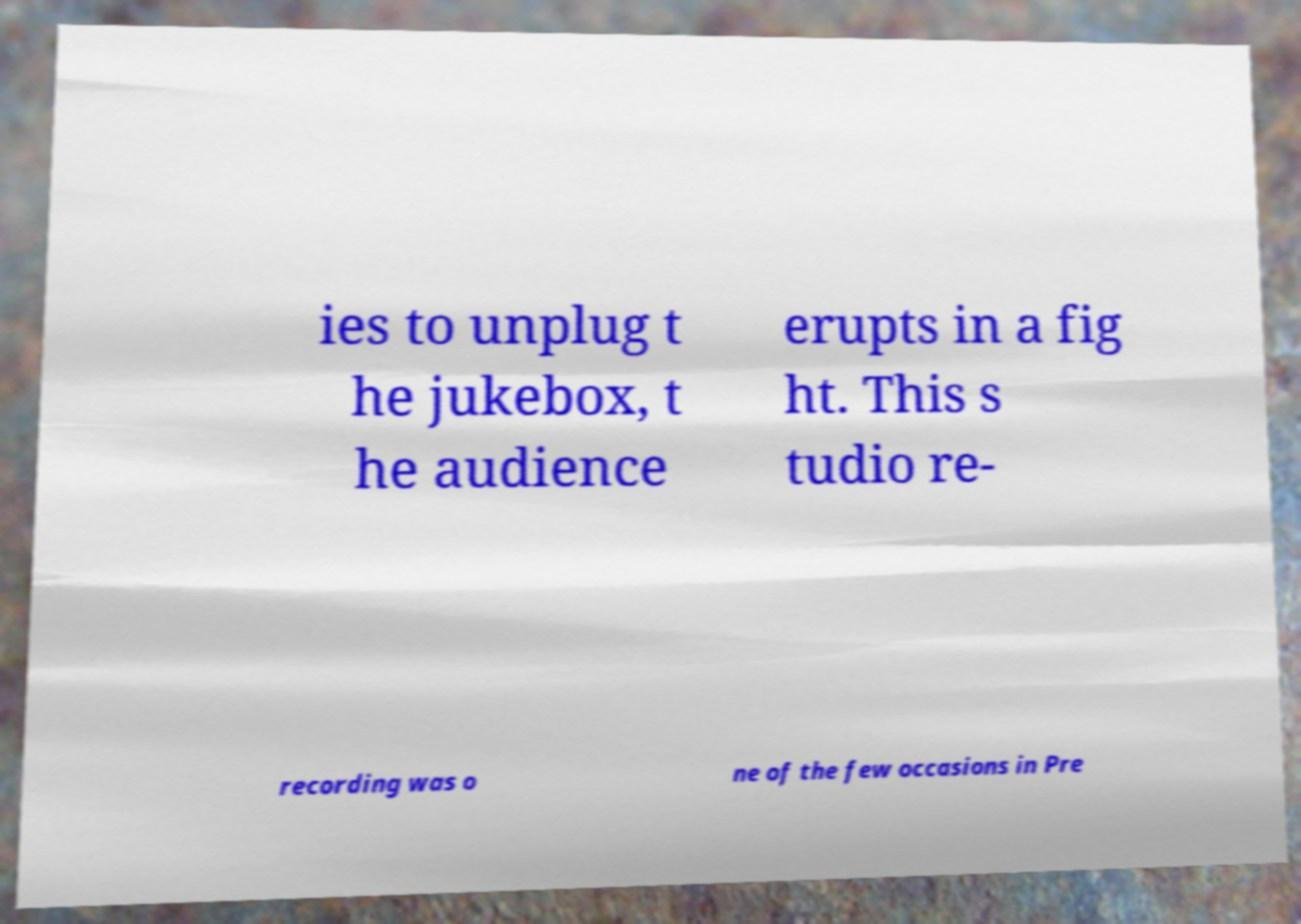There's text embedded in this image that I need extracted. Can you transcribe it verbatim? ies to unplug t he jukebox, t he audience erupts in a fig ht. This s tudio re- recording was o ne of the few occasions in Pre 